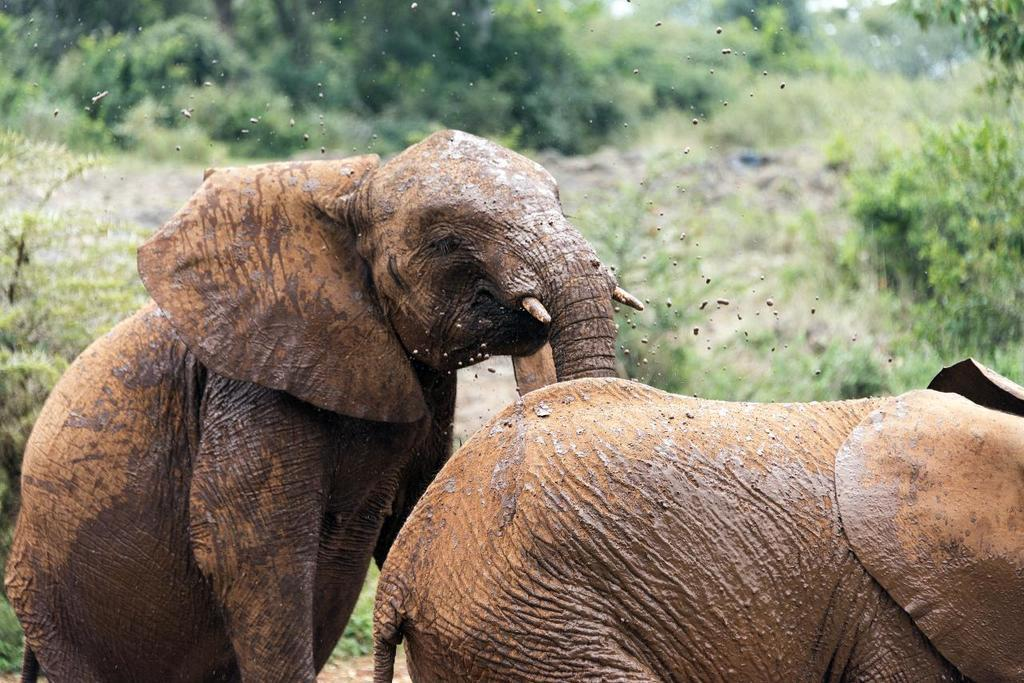What animals are in the foreground of the image? There are two muddy elephants in the foreground of the image. What can be seen in the background of the image? There are trees in the background of the image. What type of dress is the doll wearing in the image? There are no dolls or dresses present in the image; it features two muddy elephants and trees in the background. 